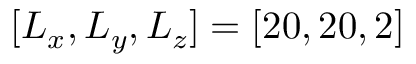<formula> <loc_0><loc_0><loc_500><loc_500>[ L _ { x } , L _ { y } , L _ { z } ] = [ 2 0 , 2 0 , 2 ]</formula> 